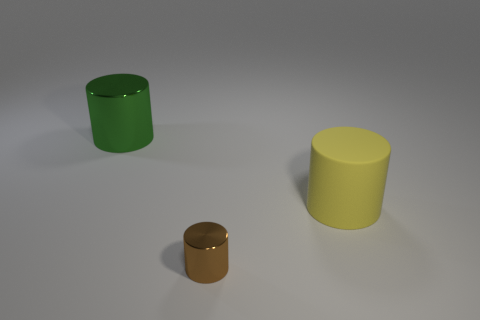Does the green metal cylinder have the same size as the yellow cylinder?
Ensure brevity in your answer.  Yes. There is a big thing that is in front of the shiny cylinder behind the large yellow rubber cylinder that is right of the tiny thing; what is its shape?
Provide a succinct answer. Cylinder. What color is the tiny thing that is the same shape as the big metal thing?
Provide a succinct answer. Brown. There is a object that is both to the left of the big yellow matte cylinder and in front of the green metallic thing; what is its size?
Offer a very short reply. Small. What number of green metal things are to the left of the shiny object to the right of the big cylinder left of the tiny metallic object?
Provide a succinct answer. 1. What number of big things are green cylinders or yellow things?
Make the answer very short. 2. Is the material of the big cylinder right of the large green shiny thing the same as the tiny brown object?
Your answer should be compact. No. There is a cylinder to the right of the shiny cylinder that is in front of the thing that is on the left side of the small metallic thing; what is its material?
Your response must be concise. Rubber. Is there anything else that is the same size as the brown metallic cylinder?
Offer a terse response. No. How many metal things are either purple spheres or small cylinders?
Your response must be concise. 1. 